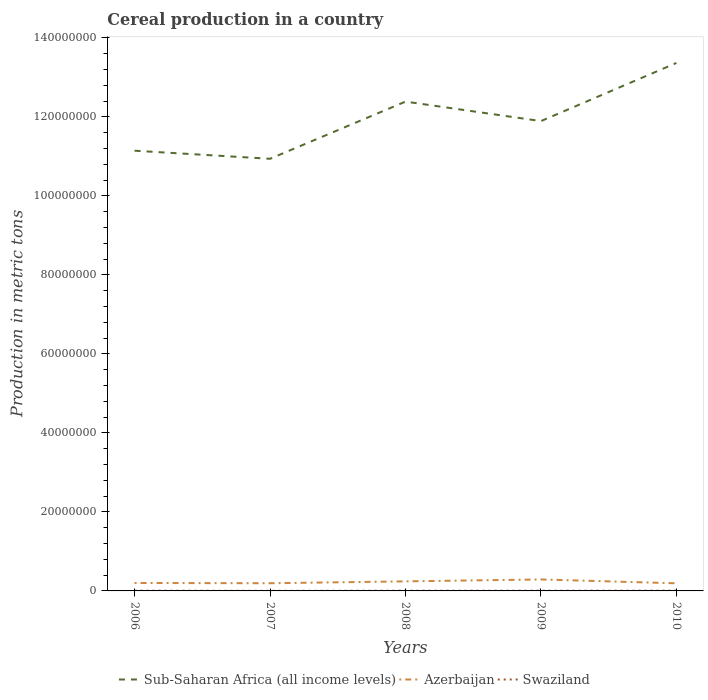Across all years, what is the maximum total cereal production in Sub-Saharan Africa (all income levels)?
Offer a very short reply. 1.09e+08. What is the total total cereal production in Sub-Saharan Africa (all income levels) in the graph?
Your answer should be compact. -9.54e+06. What is the difference between the highest and the second highest total cereal production in Azerbaijan?
Keep it short and to the point. 9.75e+05. What is the difference between the highest and the lowest total cereal production in Swaziland?
Offer a terse response. 4. How many years are there in the graph?
Provide a succinct answer. 5. Does the graph contain any zero values?
Keep it short and to the point. No. Does the graph contain grids?
Your answer should be compact. No. How many legend labels are there?
Provide a short and direct response. 3. What is the title of the graph?
Provide a succinct answer. Cereal production in a country. What is the label or title of the X-axis?
Provide a succinct answer. Years. What is the label or title of the Y-axis?
Your answer should be very brief. Production in metric tons. What is the Production in metric tons in Sub-Saharan Africa (all income levels) in 2006?
Offer a terse response. 1.11e+08. What is the Production in metric tons of Azerbaijan in 2006?
Provide a succinct answer. 2.01e+06. What is the Production in metric tons of Swaziland in 2006?
Offer a very short reply. 6.77e+04. What is the Production in metric tons of Sub-Saharan Africa (all income levels) in 2007?
Your answer should be compact. 1.09e+08. What is the Production in metric tons of Azerbaijan in 2007?
Your response must be concise. 1.94e+06. What is the Production in metric tons in Swaziland in 2007?
Provide a short and direct response. 2.69e+04. What is the Production in metric tons of Sub-Saharan Africa (all income levels) in 2008?
Keep it short and to the point. 1.24e+08. What is the Production in metric tons in Azerbaijan in 2008?
Keep it short and to the point. 2.42e+06. What is the Production in metric tons of Swaziland in 2008?
Provide a succinct answer. 6.08e+04. What is the Production in metric tons in Sub-Saharan Africa (all income levels) in 2009?
Provide a succinct answer. 1.19e+08. What is the Production in metric tons of Azerbaijan in 2009?
Your answer should be compact. 2.90e+06. What is the Production in metric tons of Swaziland in 2009?
Your response must be concise. 5.79e+04. What is the Production in metric tons of Sub-Saharan Africa (all income levels) in 2010?
Provide a succinct answer. 1.34e+08. What is the Production in metric tons of Azerbaijan in 2010?
Your answer should be very brief. 1.93e+06. What is the Production in metric tons in Swaziland in 2010?
Ensure brevity in your answer.  6.89e+04. Across all years, what is the maximum Production in metric tons in Sub-Saharan Africa (all income levels)?
Your answer should be very brief. 1.34e+08. Across all years, what is the maximum Production in metric tons of Azerbaijan?
Your answer should be very brief. 2.90e+06. Across all years, what is the maximum Production in metric tons in Swaziland?
Provide a succinct answer. 6.89e+04. Across all years, what is the minimum Production in metric tons in Sub-Saharan Africa (all income levels)?
Offer a very short reply. 1.09e+08. Across all years, what is the minimum Production in metric tons of Azerbaijan?
Provide a succinct answer. 1.93e+06. Across all years, what is the minimum Production in metric tons of Swaziland?
Ensure brevity in your answer.  2.69e+04. What is the total Production in metric tons of Sub-Saharan Africa (all income levels) in the graph?
Keep it short and to the point. 5.97e+08. What is the total Production in metric tons in Azerbaijan in the graph?
Give a very brief answer. 1.12e+07. What is the total Production in metric tons in Swaziland in the graph?
Your response must be concise. 2.82e+05. What is the difference between the Production in metric tons in Sub-Saharan Africa (all income levels) in 2006 and that in 2007?
Your answer should be very brief. 2.04e+06. What is the difference between the Production in metric tons of Azerbaijan in 2006 and that in 2007?
Your answer should be very brief. 6.79e+04. What is the difference between the Production in metric tons of Swaziland in 2006 and that in 2007?
Provide a succinct answer. 4.08e+04. What is the difference between the Production in metric tons of Sub-Saharan Africa (all income levels) in 2006 and that in 2008?
Your answer should be very brief. -1.24e+07. What is the difference between the Production in metric tons of Azerbaijan in 2006 and that in 2008?
Provide a succinct answer. -4.08e+05. What is the difference between the Production in metric tons of Swaziland in 2006 and that in 2008?
Make the answer very short. 6892. What is the difference between the Production in metric tons of Sub-Saharan Africa (all income levels) in 2006 and that in 2009?
Your answer should be very brief. -7.50e+06. What is the difference between the Production in metric tons of Azerbaijan in 2006 and that in 2009?
Give a very brief answer. -8.92e+05. What is the difference between the Production in metric tons in Swaziland in 2006 and that in 2009?
Your answer should be very brief. 9825. What is the difference between the Production in metric tons in Sub-Saharan Africa (all income levels) in 2006 and that in 2010?
Your answer should be compact. -2.22e+07. What is the difference between the Production in metric tons in Azerbaijan in 2006 and that in 2010?
Provide a succinct answer. 8.28e+04. What is the difference between the Production in metric tons in Swaziland in 2006 and that in 2010?
Ensure brevity in your answer.  -1195. What is the difference between the Production in metric tons in Sub-Saharan Africa (all income levels) in 2007 and that in 2008?
Your response must be concise. -1.45e+07. What is the difference between the Production in metric tons in Azerbaijan in 2007 and that in 2008?
Provide a short and direct response. -4.76e+05. What is the difference between the Production in metric tons in Swaziland in 2007 and that in 2008?
Provide a succinct answer. -3.39e+04. What is the difference between the Production in metric tons of Sub-Saharan Africa (all income levels) in 2007 and that in 2009?
Ensure brevity in your answer.  -9.54e+06. What is the difference between the Production in metric tons of Azerbaijan in 2007 and that in 2009?
Your response must be concise. -9.60e+05. What is the difference between the Production in metric tons of Swaziland in 2007 and that in 2009?
Your answer should be compact. -3.10e+04. What is the difference between the Production in metric tons of Sub-Saharan Africa (all income levels) in 2007 and that in 2010?
Give a very brief answer. -2.43e+07. What is the difference between the Production in metric tons of Azerbaijan in 2007 and that in 2010?
Make the answer very short. 1.49e+04. What is the difference between the Production in metric tons of Swaziland in 2007 and that in 2010?
Offer a terse response. -4.20e+04. What is the difference between the Production in metric tons of Sub-Saharan Africa (all income levels) in 2008 and that in 2009?
Make the answer very short. 4.93e+06. What is the difference between the Production in metric tons in Azerbaijan in 2008 and that in 2009?
Offer a very short reply. -4.83e+05. What is the difference between the Production in metric tons of Swaziland in 2008 and that in 2009?
Ensure brevity in your answer.  2933. What is the difference between the Production in metric tons in Sub-Saharan Africa (all income levels) in 2008 and that in 2010?
Your response must be concise. -9.78e+06. What is the difference between the Production in metric tons of Azerbaijan in 2008 and that in 2010?
Provide a succinct answer. 4.91e+05. What is the difference between the Production in metric tons in Swaziland in 2008 and that in 2010?
Make the answer very short. -8087. What is the difference between the Production in metric tons in Sub-Saharan Africa (all income levels) in 2009 and that in 2010?
Provide a succinct answer. -1.47e+07. What is the difference between the Production in metric tons in Azerbaijan in 2009 and that in 2010?
Your answer should be compact. 9.75e+05. What is the difference between the Production in metric tons of Swaziland in 2009 and that in 2010?
Keep it short and to the point. -1.10e+04. What is the difference between the Production in metric tons in Sub-Saharan Africa (all income levels) in 2006 and the Production in metric tons in Azerbaijan in 2007?
Your response must be concise. 1.09e+08. What is the difference between the Production in metric tons in Sub-Saharan Africa (all income levels) in 2006 and the Production in metric tons in Swaziland in 2007?
Your answer should be compact. 1.11e+08. What is the difference between the Production in metric tons in Azerbaijan in 2006 and the Production in metric tons in Swaziland in 2007?
Your response must be concise. 1.98e+06. What is the difference between the Production in metric tons of Sub-Saharan Africa (all income levels) in 2006 and the Production in metric tons of Azerbaijan in 2008?
Your answer should be very brief. 1.09e+08. What is the difference between the Production in metric tons in Sub-Saharan Africa (all income levels) in 2006 and the Production in metric tons in Swaziland in 2008?
Ensure brevity in your answer.  1.11e+08. What is the difference between the Production in metric tons of Azerbaijan in 2006 and the Production in metric tons of Swaziland in 2008?
Offer a terse response. 1.95e+06. What is the difference between the Production in metric tons of Sub-Saharan Africa (all income levels) in 2006 and the Production in metric tons of Azerbaijan in 2009?
Your answer should be very brief. 1.09e+08. What is the difference between the Production in metric tons of Sub-Saharan Africa (all income levels) in 2006 and the Production in metric tons of Swaziland in 2009?
Make the answer very short. 1.11e+08. What is the difference between the Production in metric tons in Azerbaijan in 2006 and the Production in metric tons in Swaziland in 2009?
Your response must be concise. 1.95e+06. What is the difference between the Production in metric tons of Sub-Saharan Africa (all income levels) in 2006 and the Production in metric tons of Azerbaijan in 2010?
Keep it short and to the point. 1.09e+08. What is the difference between the Production in metric tons of Sub-Saharan Africa (all income levels) in 2006 and the Production in metric tons of Swaziland in 2010?
Keep it short and to the point. 1.11e+08. What is the difference between the Production in metric tons of Azerbaijan in 2006 and the Production in metric tons of Swaziland in 2010?
Give a very brief answer. 1.94e+06. What is the difference between the Production in metric tons of Sub-Saharan Africa (all income levels) in 2007 and the Production in metric tons of Azerbaijan in 2008?
Ensure brevity in your answer.  1.07e+08. What is the difference between the Production in metric tons of Sub-Saharan Africa (all income levels) in 2007 and the Production in metric tons of Swaziland in 2008?
Your answer should be compact. 1.09e+08. What is the difference between the Production in metric tons of Azerbaijan in 2007 and the Production in metric tons of Swaziland in 2008?
Ensure brevity in your answer.  1.88e+06. What is the difference between the Production in metric tons of Sub-Saharan Africa (all income levels) in 2007 and the Production in metric tons of Azerbaijan in 2009?
Provide a short and direct response. 1.06e+08. What is the difference between the Production in metric tons in Sub-Saharan Africa (all income levels) in 2007 and the Production in metric tons in Swaziland in 2009?
Offer a very short reply. 1.09e+08. What is the difference between the Production in metric tons of Azerbaijan in 2007 and the Production in metric tons of Swaziland in 2009?
Your answer should be very brief. 1.89e+06. What is the difference between the Production in metric tons in Sub-Saharan Africa (all income levels) in 2007 and the Production in metric tons in Azerbaijan in 2010?
Your response must be concise. 1.07e+08. What is the difference between the Production in metric tons of Sub-Saharan Africa (all income levels) in 2007 and the Production in metric tons of Swaziland in 2010?
Your response must be concise. 1.09e+08. What is the difference between the Production in metric tons in Azerbaijan in 2007 and the Production in metric tons in Swaziland in 2010?
Make the answer very short. 1.87e+06. What is the difference between the Production in metric tons in Sub-Saharan Africa (all income levels) in 2008 and the Production in metric tons in Azerbaijan in 2009?
Give a very brief answer. 1.21e+08. What is the difference between the Production in metric tons of Sub-Saharan Africa (all income levels) in 2008 and the Production in metric tons of Swaziland in 2009?
Offer a very short reply. 1.24e+08. What is the difference between the Production in metric tons of Azerbaijan in 2008 and the Production in metric tons of Swaziland in 2009?
Offer a very short reply. 2.36e+06. What is the difference between the Production in metric tons in Sub-Saharan Africa (all income levels) in 2008 and the Production in metric tons in Azerbaijan in 2010?
Provide a succinct answer. 1.22e+08. What is the difference between the Production in metric tons in Sub-Saharan Africa (all income levels) in 2008 and the Production in metric tons in Swaziland in 2010?
Ensure brevity in your answer.  1.24e+08. What is the difference between the Production in metric tons in Azerbaijan in 2008 and the Production in metric tons in Swaziland in 2010?
Make the answer very short. 2.35e+06. What is the difference between the Production in metric tons of Sub-Saharan Africa (all income levels) in 2009 and the Production in metric tons of Azerbaijan in 2010?
Ensure brevity in your answer.  1.17e+08. What is the difference between the Production in metric tons of Sub-Saharan Africa (all income levels) in 2009 and the Production in metric tons of Swaziland in 2010?
Offer a very short reply. 1.19e+08. What is the difference between the Production in metric tons in Azerbaijan in 2009 and the Production in metric tons in Swaziland in 2010?
Offer a terse response. 2.83e+06. What is the average Production in metric tons in Sub-Saharan Africa (all income levels) per year?
Provide a succinct answer. 1.19e+08. What is the average Production in metric tons in Azerbaijan per year?
Offer a terse response. 2.24e+06. What is the average Production in metric tons of Swaziland per year?
Offer a terse response. 5.65e+04. In the year 2006, what is the difference between the Production in metric tons in Sub-Saharan Africa (all income levels) and Production in metric tons in Azerbaijan?
Provide a succinct answer. 1.09e+08. In the year 2006, what is the difference between the Production in metric tons of Sub-Saharan Africa (all income levels) and Production in metric tons of Swaziland?
Provide a short and direct response. 1.11e+08. In the year 2006, what is the difference between the Production in metric tons of Azerbaijan and Production in metric tons of Swaziland?
Provide a succinct answer. 1.94e+06. In the year 2007, what is the difference between the Production in metric tons of Sub-Saharan Africa (all income levels) and Production in metric tons of Azerbaijan?
Keep it short and to the point. 1.07e+08. In the year 2007, what is the difference between the Production in metric tons in Sub-Saharan Africa (all income levels) and Production in metric tons in Swaziland?
Provide a succinct answer. 1.09e+08. In the year 2007, what is the difference between the Production in metric tons of Azerbaijan and Production in metric tons of Swaziland?
Your answer should be compact. 1.92e+06. In the year 2008, what is the difference between the Production in metric tons of Sub-Saharan Africa (all income levels) and Production in metric tons of Azerbaijan?
Offer a terse response. 1.21e+08. In the year 2008, what is the difference between the Production in metric tons of Sub-Saharan Africa (all income levels) and Production in metric tons of Swaziland?
Offer a terse response. 1.24e+08. In the year 2008, what is the difference between the Production in metric tons in Azerbaijan and Production in metric tons in Swaziland?
Your answer should be very brief. 2.36e+06. In the year 2009, what is the difference between the Production in metric tons of Sub-Saharan Africa (all income levels) and Production in metric tons of Azerbaijan?
Keep it short and to the point. 1.16e+08. In the year 2009, what is the difference between the Production in metric tons in Sub-Saharan Africa (all income levels) and Production in metric tons in Swaziland?
Make the answer very short. 1.19e+08. In the year 2009, what is the difference between the Production in metric tons of Azerbaijan and Production in metric tons of Swaziland?
Your answer should be very brief. 2.85e+06. In the year 2010, what is the difference between the Production in metric tons of Sub-Saharan Africa (all income levels) and Production in metric tons of Azerbaijan?
Your response must be concise. 1.32e+08. In the year 2010, what is the difference between the Production in metric tons of Sub-Saharan Africa (all income levels) and Production in metric tons of Swaziland?
Offer a terse response. 1.34e+08. In the year 2010, what is the difference between the Production in metric tons in Azerbaijan and Production in metric tons in Swaziland?
Your answer should be very brief. 1.86e+06. What is the ratio of the Production in metric tons of Sub-Saharan Africa (all income levels) in 2006 to that in 2007?
Give a very brief answer. 1.02. What is the ratio of the Production in metric tons in Azerbaijan in 2006 to that in 2007?
Your answer should be compact. 1.03. What is the ratio of the Production in metric tons of Swaziland in 2006 to that in 2007?
Your answer should be compact. 2.52. What is the ratio of the Production in metric tons of Sub-Saharan Africa (all income levels) in 2006 to that in 2008?
Your answer should be compact. 0.9. What is the ratio of the Production in metric tons of Azerbaijan in 2006 to that in 2008?
Offer a very short reply. 0.83. What is the ratio of the Production in metric tons in Swaziland in 2006 to that in 2008?
Keep it short and to the point. 1.11. What is the ratio of the Production in metric tons in Sub-Saharan Africa (all income levels) in 2006 to that in 2009?
Your response must be concise. 0.94. What is the ratio of the Production in metric tons in Azerbaijan in 2006 to that in 2009?
Give a very brief answer. 0.69. What is the ratio of the Production in metric tons in Swaziland in 2006 to that in 2009?
Your answer should be compact. 1.17. What is the ratio of the Production in metric tons of Sub-Saharan Africa (all income levels) in 2006 to that in 2010?
Give a very brief answer. 0.83. What is the ratio of the Production in metric tons of Azerbaijan in 2006 to that in 2010?
Make the answer very short. 1.04. What is the ratio of the Production in metric tons in Swaziland in 2006 to that in 2010?
Give a very brief answer. 0.98. What is the ratio of the Production in metric tons of Sub-Saharan Africa (all income levels) in 2007 to that in 2008?
Ensure brevity in your answer.  0.88. What is the ratio of the Production in metric tons in Azerbaijan in 2007 to that in 2008?
Ensure brevity in your answer.  0.8. What is the ratio of the Production in metric tons in Swaziland in 2007 to that in 2008?
Make the answer very short. 0.44. What is the ratio of the Production in metric tons of Sub-Saharan Africa (all income levels) in 2007 to that in 2009?
Provide a succinct answer. 0.92. What is the ratio of the Production in metric tons of Azerbaijan in 2007 to that in 2009?
Provide a short and direct response. 0.67. What is the ratio of the Production in metric tons in Swaziland in 2007 to that in 2009?
Offer a terse response. 0.46. What is the ratio of the Production in metric tons in Sub-Saharan Africa (all income levels) in 2007 to that in 2010?
Provide a succinct answer. 0.82. What is the ratio of the Production in metric tons in Azerbaijan in 2007 to that in 2010?
Provide a short and direct response. 1.01. What is the ratio of the Production in metric tons in Swaziland in 2007 to that in 2010?
Ensure brevity in your answer.  0.39. What is the ratio of the Production in metric tons of Sub-Saharan Africa (all income levels) in 2008 to that in 2009?
Offer a very short reply. 1.04. What is the ratio of the Production in metric tons of Azerbaijan in 2008 to that in 2009?
Your answer should be very brief. 0.83. What is the ratio of the Production in metric tons in Swaziland in 2008 to that in 2009?
Keep it short and to the point. 1.05. What is the ratio of the Production in metric tons in Sub-Saharan Africa (all income levels) in 2008 to that in 2010?
Make the answer very short. 0.93. What is the ratio of the Production in metric tons of Azerbaijan in 2008 to that in 2010?
Offer a very short reply. 1.25. What is the ratio of the Production in metric tons in Swaziland in 2008 to that in 2010?
Ensure brevity in your answer.  0.88. What is the ratio of the Production in metric tons of Sub-Saharan Africa (all income levels) in 2009 to that in 2010?
Give a very brief answer. 0.89. What is the ratio of the Production in metric tons of Azerbaijan in 2009 to that in 2010?
Ensure brevity in your answer.  1.51. What is the ratio of the Production in metric tons in Swaziland in 2009 to that in 2010?
Your answer should be very brief. 0.84. What is the difference between the highest and the second highest Production in metric tons of Sub-Saharan Africa (all income levels)?
Your response must be concise. 9.78e+06. What is the difference between the highest and the second highest Production in metric tons in Azerbaijan?
Make the answer very short. 4.83e+05. What is the difference between the highest and the second highest Production in metric tons of Swaziland?
Offer a very short reply. 1195. What is the difference between the highest and the lowest Production in metric tons in Sub-Saharan Africa (all income levels)?
Offer a very short reply. 2.43e+07. What is the difference between the highest and the lowest Production in metric tons of Azerbaijan?
Make the answer very short. 9.75e+05. What is the difference between the highest and the lowest Production in metric tons of Swaziland?
Provide a short and direct response. 4.20e+04. 